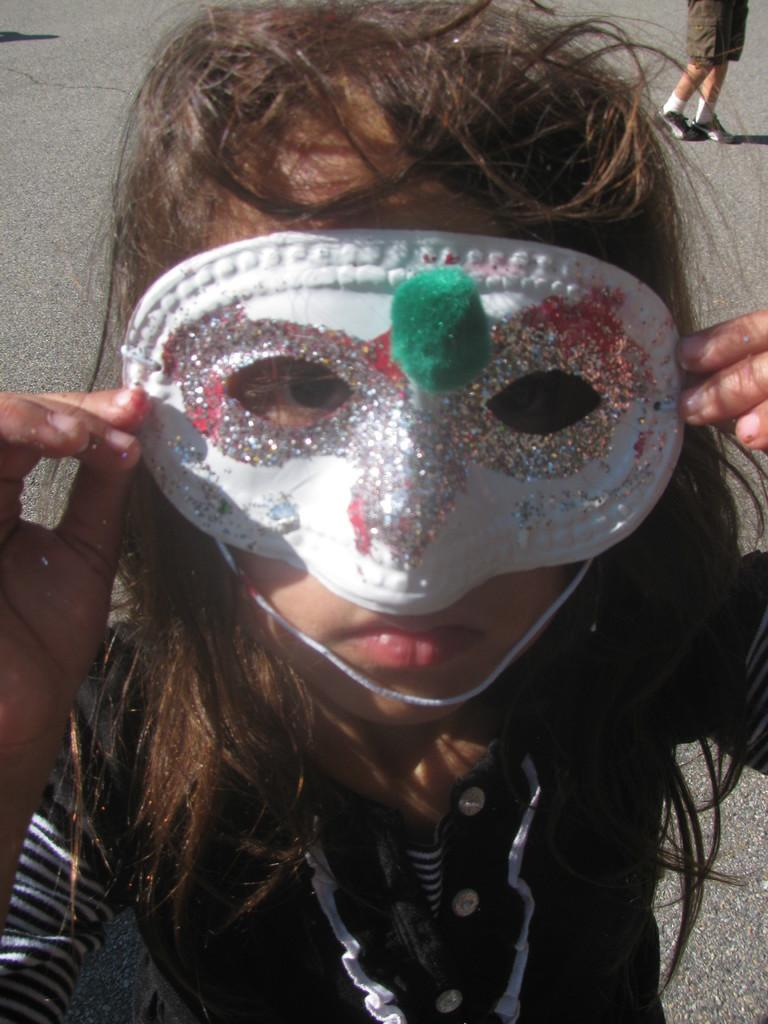How many people are in the image? There are people in the image, but the exact number is not specified. What can be seen in the background of the image? There is a road in the image. What is the person holding in her hand? A person is holding an object in her hand, but the specific object is not described. What thought is going through the person's mind in the image? There is no information provided about the person's thoughts in the image. 